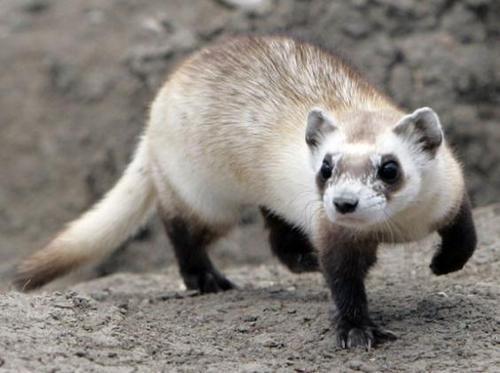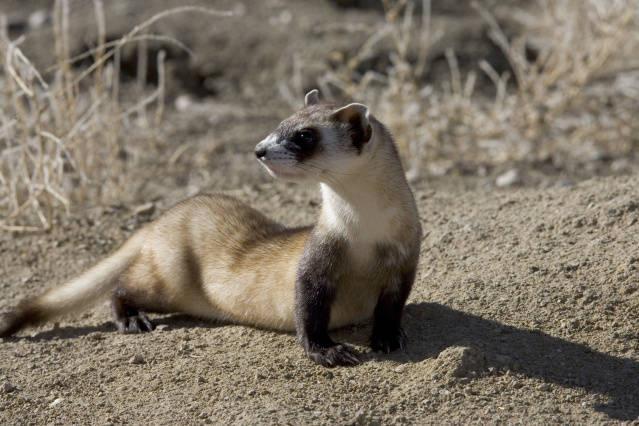The first image is the image on the left, the second image is the image on the right. Given the left and right images, does the statement "Two animals are standing on the dirt in one of the images." hold true? Answer yes or no. No. The first image is the image on the left, the second image is the image on the right. Assess this claim about the two images: "An image shows a camera-facing ferret emerging from a hole in the ground.". Correct or not? Answer yes or no. No. 